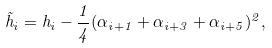<formula> <loc_0><loc_0><loc_500><loc_500>\tilde { h } _ { i } = h _ { i } - \frac { 1 } { 4 } ( \alpha _ { i + 1 } + \alpha _ { i + 3 } + \alpha _ { i + 5 } ) ^ { 2 } ,</formula> 